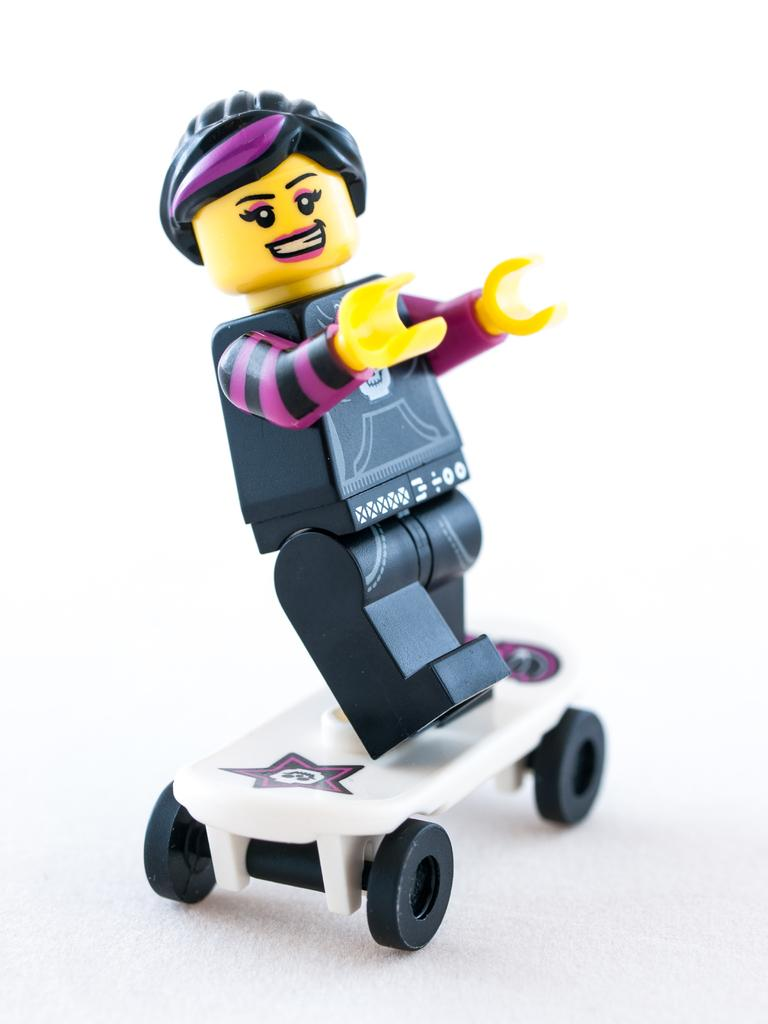What is the main subject in the center of the image? There is a toy in the center of the image. What is the color of the surface on which the toy is placed? The toy is on a white surface. What type of soap is being used to clean the toy in the image? There is no soap or cleaning activity present in the image; it features a toy on a white surface. What type of flesh can be seen on the toy in the image? There is no flesh or any living organism present in the image; it features a toy on a white surface. 